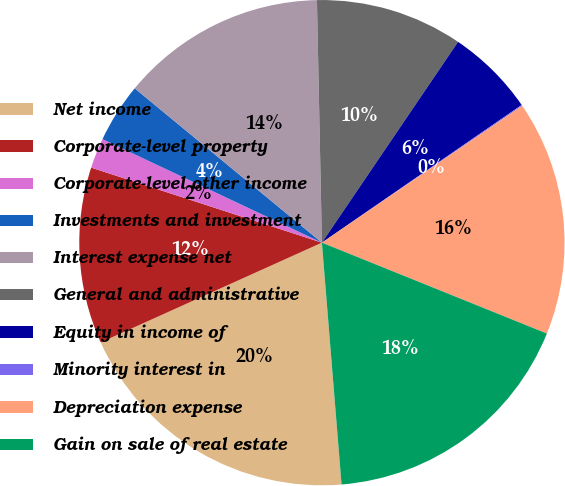<chart> <loc_0><loc_0><loc_500><loc_500><pie_chart><fcel>Net income<fcel>Corporate-level property<fcel>Corporate-level other income<fcel>Investments and investment<fcel>Interest expense net<fcel>General and administrative<fcel>Equity in income of<fcel>Minority interest in<fcel>Depreciation expense<fcel>Gain on sale of real estate<nl><fcel>19.55%<fcel>11.75%<fcel>2.01%<fcel>3.96%<fcel>13.7%<fcel>9.81%<fcel>5.91%<fcel>0.07%<fcel>15.65%<fcel>17.6%<nl></chart> 